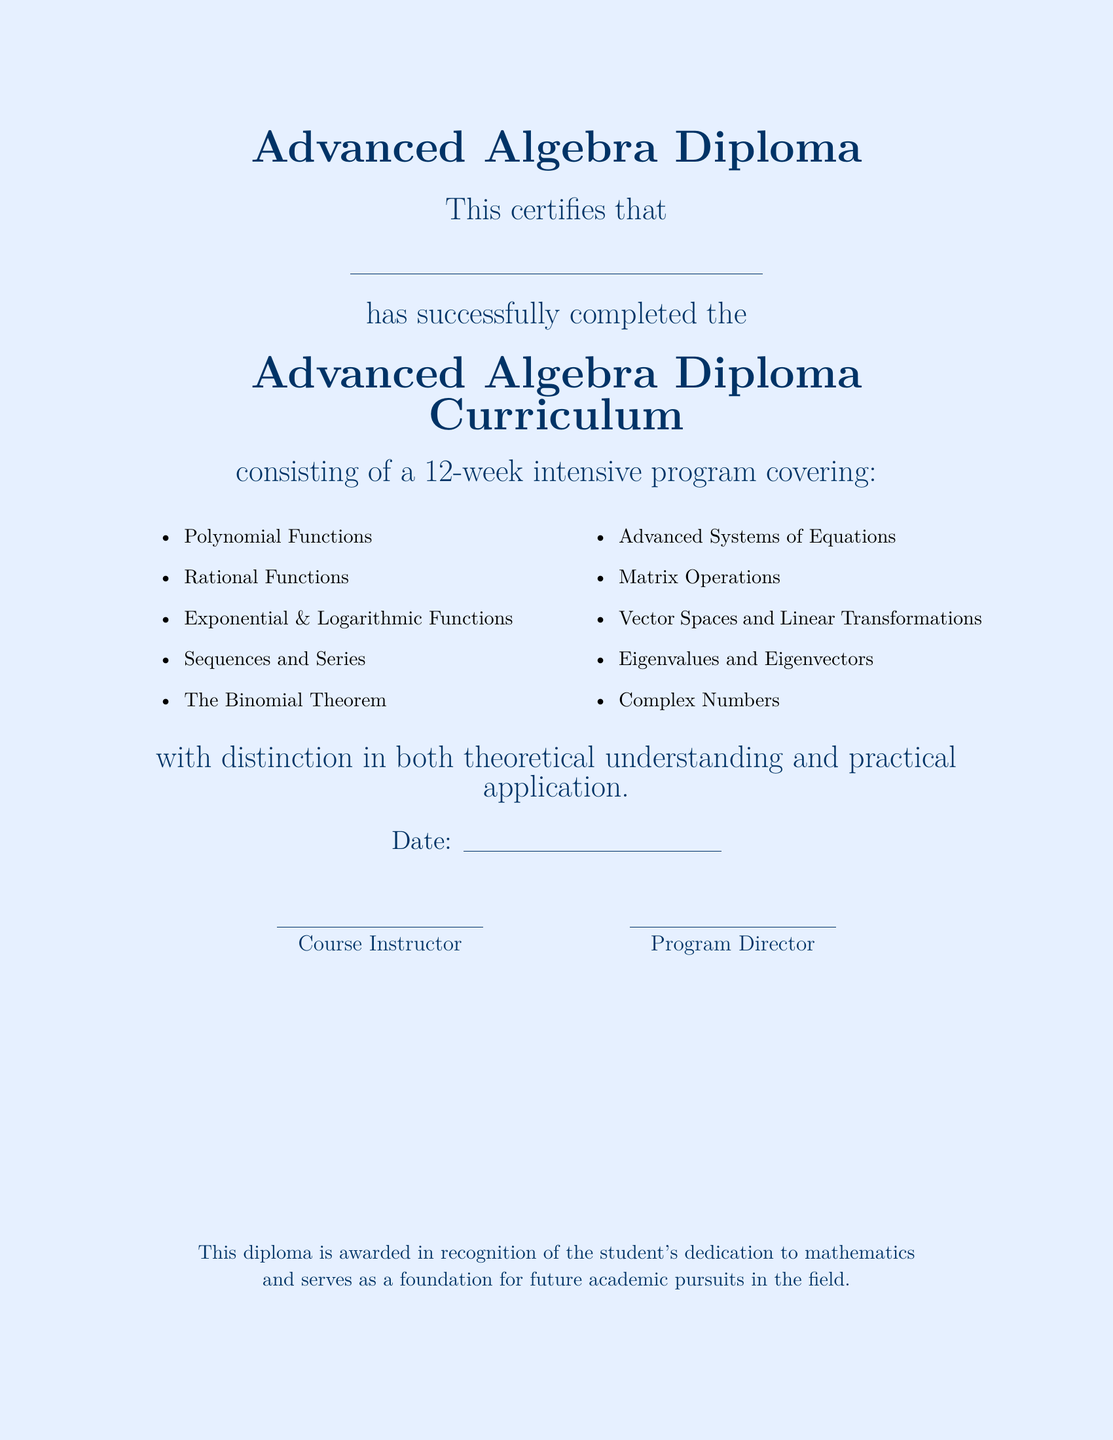What is the name of the program? The name of the program is mentioned in the title of the document.
Answer: Advanced Algebra Diploma How many weeks does the curriculum cover? The document states the duration of the program clearly.
Answer: 12 weeks What is one of the topics covered in the curriculum? The document lists various topics included in the curriculum.
Answer: Polynomial Functions Who certifies the completion of the diploma? The document indicates who has successfully completed the curriculum in the provided space.
Answer: Student's name What is stated about the nature of the completion? The document mentions the level of achievement upon completion.
Answer: with distinction What should be written in the date section? The document provides a space for recording a specific time frame.
Answer: Date Who are the two positions mentioned at the bottom of the document? The document includes titles of individuals signing the diploma.
Answer: Course Instructor and Program Director What color scheme is used in the document? The color details are specified in the document's design choices.
Answer: light blue and math blue 